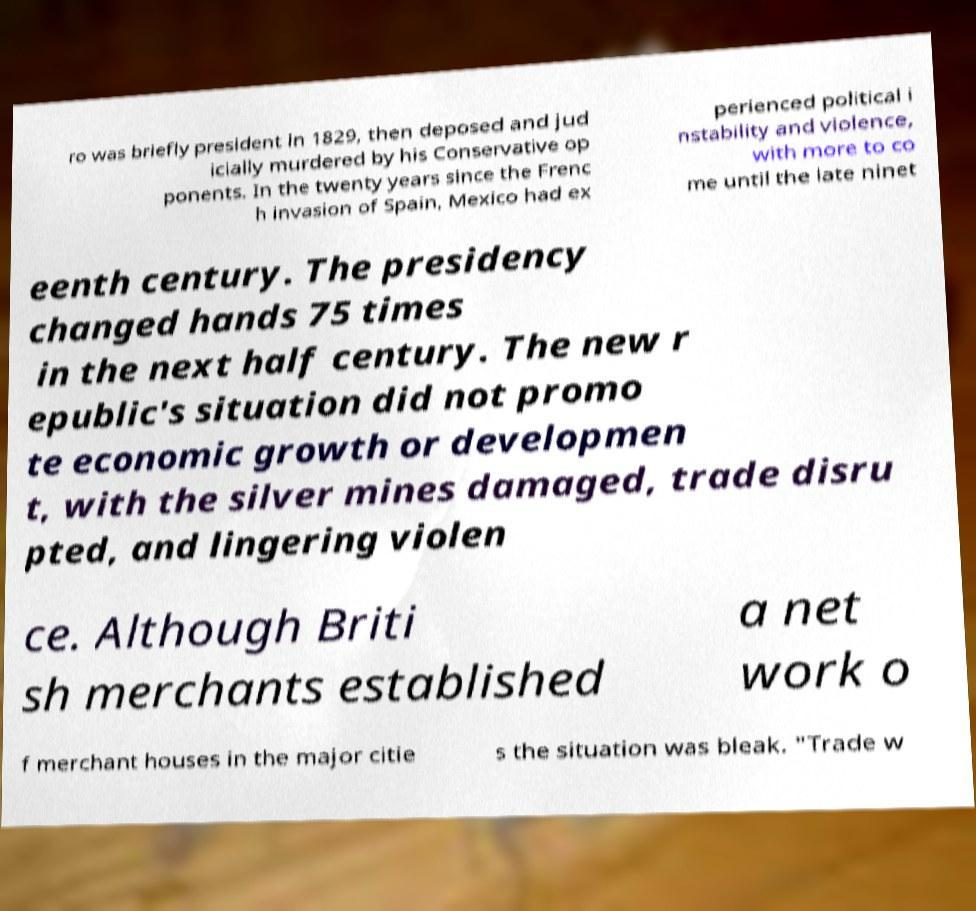Please read and relay the text visible in this image. What does it say? ro was briefly president in 1829, then deposed and jud icially murdered by his Conservative op ponents. In the twenty years since the Frenc h invasion of Spain, Mexico had ex perienced political i nstability and violence, with more to co me until the late ninet eenth century. The presidency changed hands 75 times in the next half century. The new r epublic's situation did not promo te economic growth or developmen t, with the silver mines damaged, trade disru pted, and lingering violen ce. Although Briti sh merchants established a net work o f merchant houses in the major citie s the situation was bleak. "Trade w 